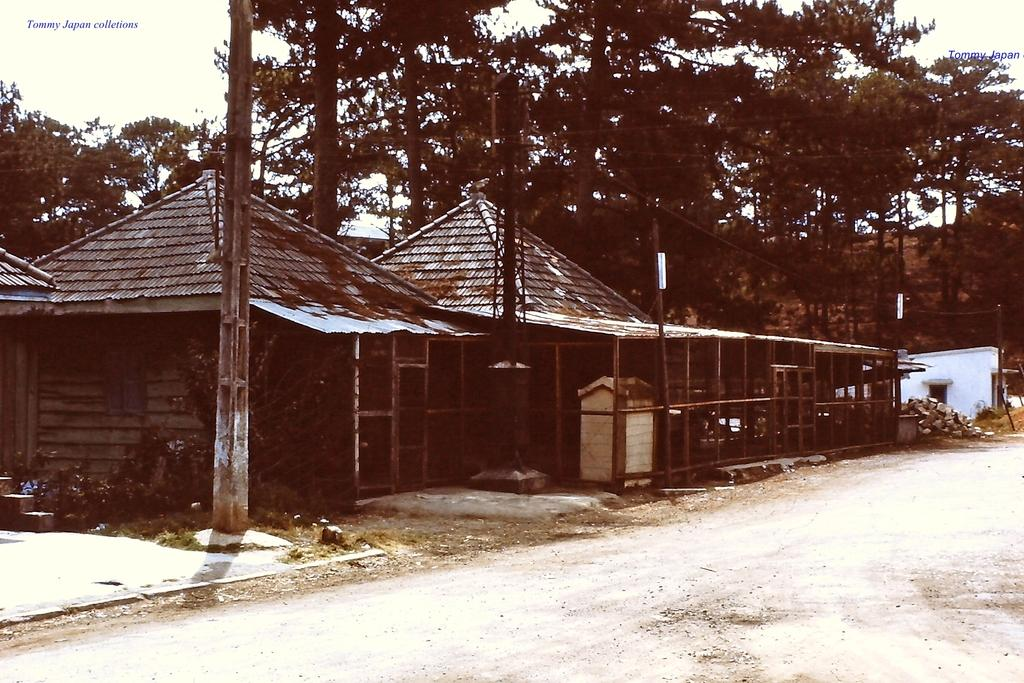What type of structures can be seen in the image? There are houses in the image. What natural elements are present in the image? There are trees, rocks, and plants in the image. What man-made objects can be seen in the image? There are poles in the image. What is visible in the background of the image? The sky is visible in the background of the image. What additional feature can be observed on the image? There are watermarks on the image. Can you tell me how many boots are hanging from the trees in the image? There are no boots present in the image; it features houses, trees, poles, rocks, plants, and the sky. What type of alarm is going off in the image? There is no alarm present in the image; it is a still image with no sounds or alarms. 